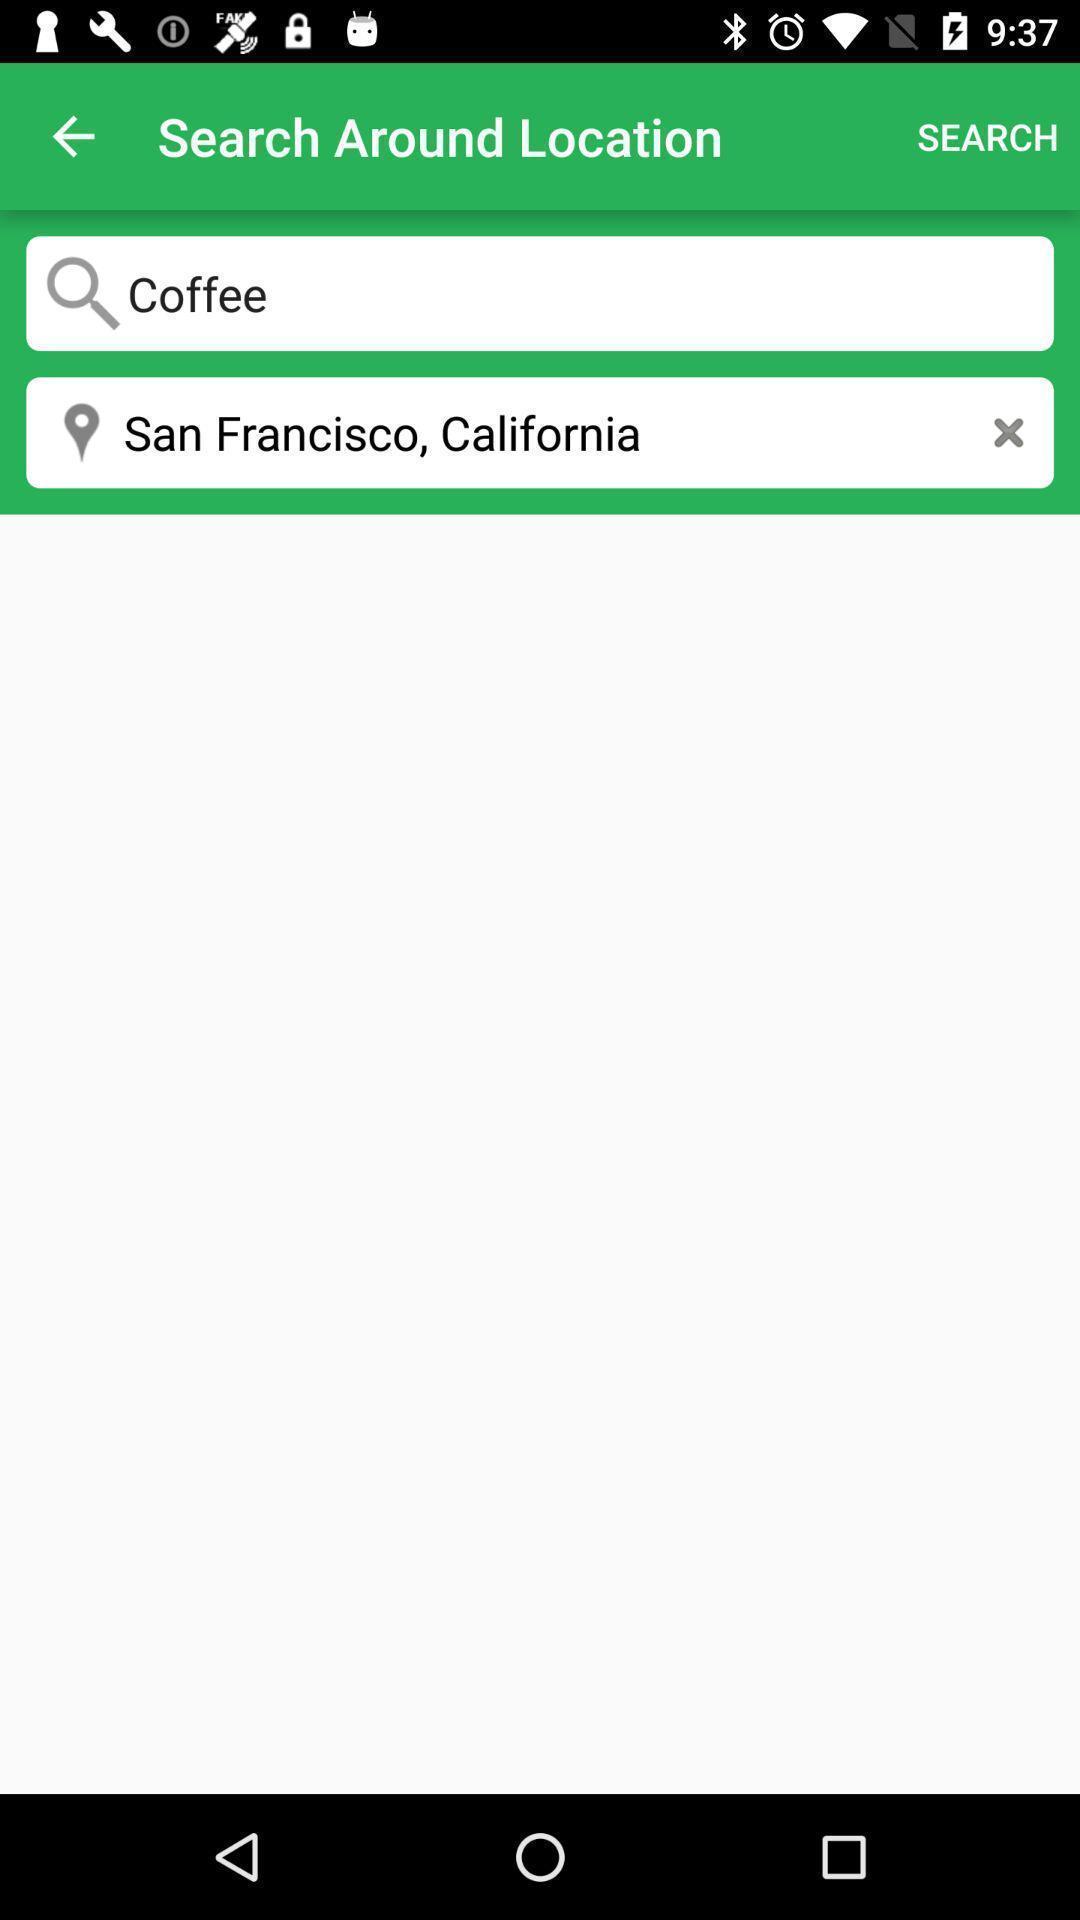What can you discern from this picture? Search bar to search around location. 